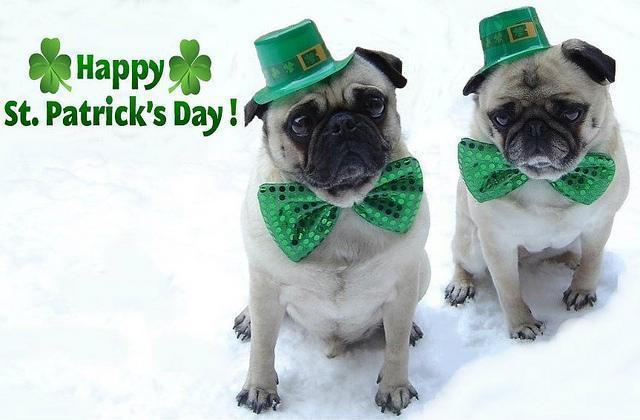What nationality is associated with the holiday being celebrated here?
Make your selection from the four choices given to correctly answer the question.
Options: Chinese, irish, french, italian. Irish. 